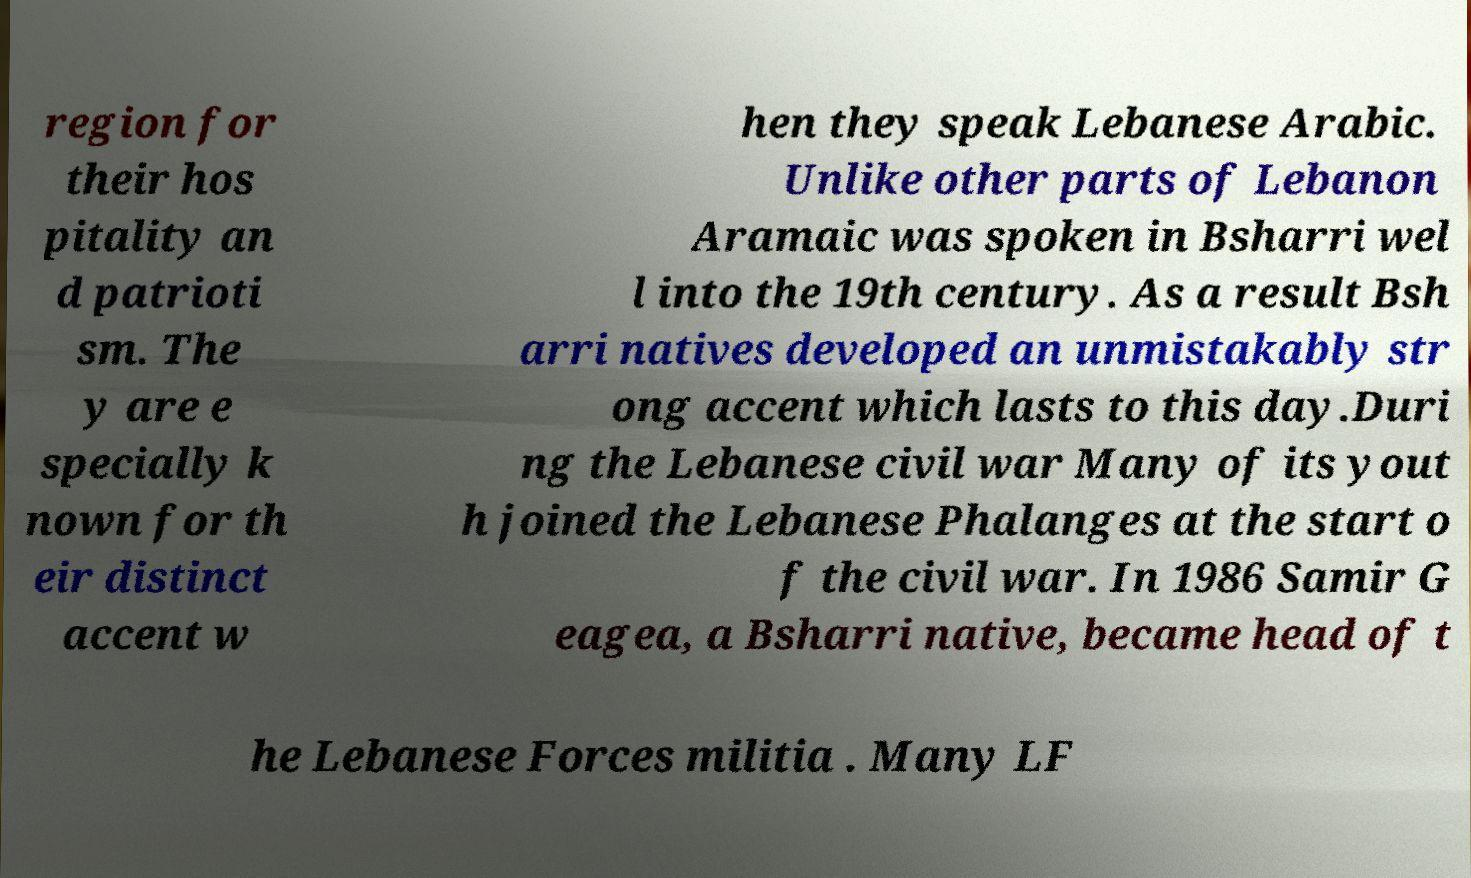Can you accurately transcribe the text from the provided image for me? region for their hos pitality an d patrioti sm. The y are e specially k nown for th eir distinct accent w hen they speak Lebanese Arabic. Unlike other parts of Lebanon Aramaic was spoken in Bsharri wel l into the 19th century. As a result Bsh arri natives developed an unmistakably str ong accent which lasts to this day.Duri ng the Lebanese civil war Many of its yout h joined the Lebanese Phalanges at the start o f the civil war. In 1986 Samir G eagea, a Bsharri native, became head of t he Lebanese Forces militia . Many LF 